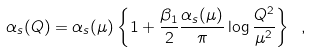Convert formula to latex. <formula><loc_0><loc_0><loc_500><loc_500>\alpha _ { s } ( Q ) = \alpha _ { s } ( \mu ) \left \{ 1 + \frac { \beta _ { 1 } } { 2 } \frac { \alpha _ { s } ( \mu ) } { \pi } \log { \frac { Q ^ { 2 } } { \mu ^ { 2 } } } \right \} \ ,</formula> 